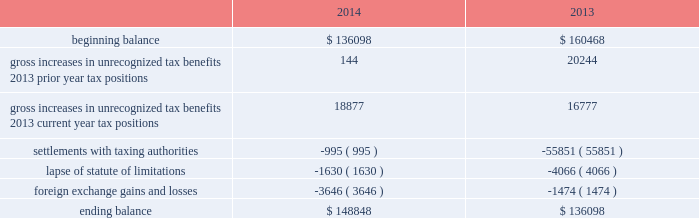Adobe systems incorporated notes to consolidated financial statements ( continued ) accounting for uncertainty in income taxes during fiscal 2014 and 2013 , our aggregate changes in our total gross amount of unrecognized tax benefits are summarized as follows ( in thousands ) : .
As of november 28 , 2014 , the combined amount of accrued interest and penalties related to tax positions taken on our tax returns and included in non-current income taxes payable was approximately $ 14.6 million .
We file income tax returns in the u.s .
On a federal basis and in many u.s .
State and foreign jurisdictions .
We are subject to the continual examination of our income tax returns by the irs and other domestic and foreign tax authorities .
Our major tax jurisdictions are ireland , california and the u.s .
For ireland , california and the u.s. , the earliest fiscal years open for examination are 2008 , 2008 and 2010 , respectively .
We regularly assess the likelihood of outcomes resulting from these examinations to determine the adequacy of our provision for income taxes and have reserved for potential adjustments that may result from the current examinations .
We believe such estimates to be reasonable ; however , there can be no assurance that the final determination of any of these examinations will not have an adverse effect on our operating results and financial position .
In july 2013 , a u.s .
Income tax examination covering fiscal 2008 and 2009 was completed .
Our accrued tax and interest related to these years was $ 48.4 million and was previously reported in long-term income taxes payable .
We settled the tax obligation resulting from this examination with cash and income tax assets totaling $ 41.2 million , and the resulting $ 7.2 million income tax benefit was recorded in the third quarter of fiscal 2013 .
The timing of the resolution of income tax examinations is highly uncertain as are the amounts and timing of tax payments that are part of any audit settlement process .
These events could cause large fluctuations in the balance sheet classification of current and non-current assets and liabilities .
We believe that within the next 12 months , it is reasonably possible that either certain audits will conclude or statutes of limitations on certain income tax examination periods will expire , or both .
Given the uncertainties described above , we can only determine a range of estimated potential decreases in underlying unrecognized tax benefits ranging from $ 0 to approximately $ 5 million .
Note 10 .
Restructuring fiscal 2014 restructuring plan in the fourth quarter of fiscal 2014 , in order to better align our global resources for digital media and digital marketing , we initiated a restructuring plan to vacate our research and development facility in china and our sales and marketing facility in russia .
This plan consisted of reductions of approximately 350 full-time positions and we recorded restructuring charges of approximately $ 18.8 million related to ongoing termination benefits for the positions eliminated .
During fiscal 2015 , we intend to vacate both of these facilities .
The amount accrued for the fair value of future contractual obligations under these operating leases was insignificant .
Other restructuring plans during the past several years , we have implemented other restructuring plans consisting of reductions in workforce and the consolidation of facilities to better align our resources around our business strategies .
As of november 28 , 2014 , we considered our other restructuring plans to be substantially complete .
We continue to make cash outlays to settle obligations under these plans , however the current impact to our consolidated financial statements is not significant. .
What is the percentage change in the total gross amount of unrecognized tax benefits from 2013 to 2014? 
Computations: ((148848 - 136098) / 136098)
Answer: 0.09368. 